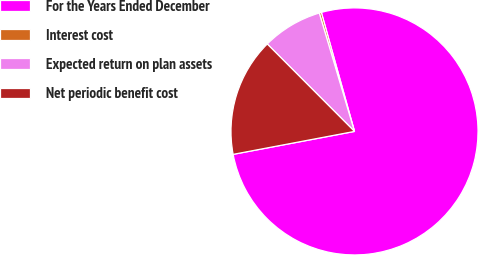Convert chart. <chart><loc_0><loc_0><loc_500><loc_500><pie_chart><fcel>For the Years Ended December<fcel>Interest cost<fcel>Expected return on plan assets<fcel>Net periodic benefit cost<nl><fcel>76.35%<fcel>0.28%<fcel>7.88%<fcel>15.49%<nl></chart> 